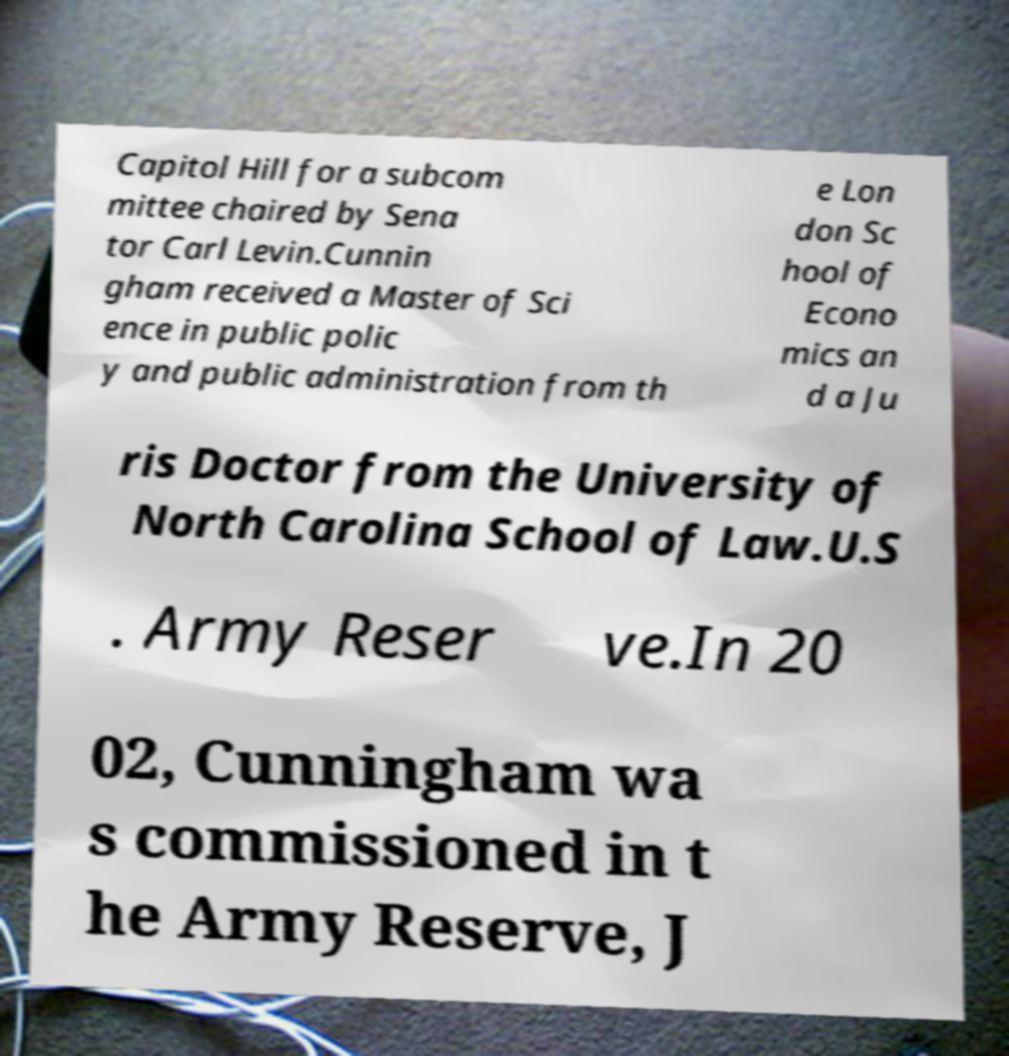Can you read and provide the text displayed in the image?This photo seems to have some interesting text. Can you extract and type it out for me? Capitol Hill for a subcom mittee chaired by Sena tor Carl Levin.Cunnin gham received a Master of Sci ence in public polic y and public administration from th e Lon don Sc hool of Econo mics an d a Ju ris Doctor from the University of North Carolina School of Law.U.S . Army Reser ve.In 20 02, Cunningham wa s commissioned in t he Army Reserve, J 